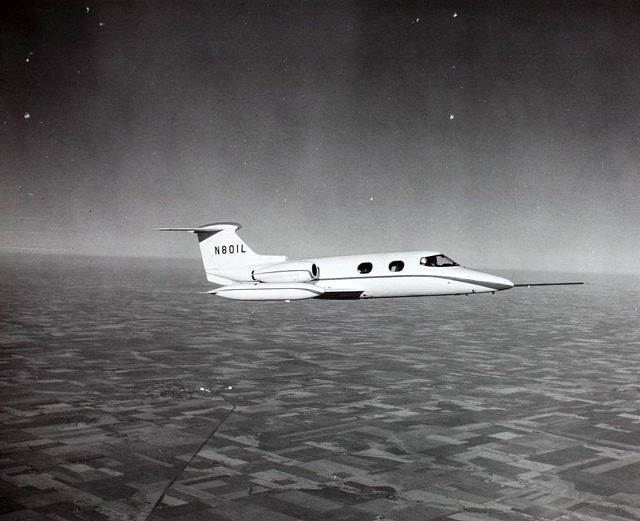Identify the text contained in this image. N80IL 